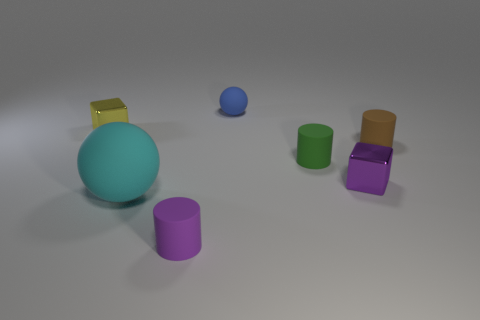Is the number of green cylinders that are in front of the brown cylinder greater than the number of tiny rubber things?
Your answer should be very brief. No. There is a small metal thing that is to the left of the block in front of the tiny yellow metal object; what color is it?
Give a very brief answer. Yellow. How many things are either small blocks that are right of the small yellow metallic cube or matte objects right of the purple shiny block?
Ensure brevity in your answer.  2. What color is the tiny sphere?
Make the answer very short. Blue. How many blue things have the same material as the tiny yellow thing?
Offer a terse response. 0. Are there more big things than blocks?
Keep it short and to the point. No. There is a metal block that is behind the green matte cylinder; how many tiny purple matte objects are behind it?
Provide a short and direct response. 0. What number of objects are small things right of the big cyan ball or blue rubber balls?
Your answer should be very brief. 5. Are there any yellow objects of the same shape as the small blue rubber object?
Provide a short and direct response. No. There is a tiny green object behind the metal thing to the right of the yellow metal block; what is its shape?
Offer a terse response. Cylinder. 